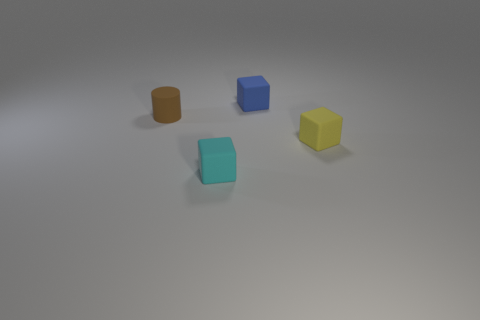Are there the same number of small cyan cubes to the left of the brown object and yellow things?
Provide a succinct answer. No. What is the shape of the cyan object that is the same size as the yellow block?
Keep it short and to the point. Cube. There is a rubber object to the left of the cyan cube; are there any tiny brown rubber things on the right side of it?
Keep it short and to the point. No. How many tiny objects are cyan blocks or cyan metal objects?
Offer a very short reply. 1. Are there any cyan things of the same size as the brown cylinder?
Provide a succinct answer. Yes. What number of metallic objects are either blue objects or small yellow things?
Provide a succinct answer. 0. How many brown cubes are there?
Provide a succinct answer. 0. Is the block to the right of the tiny blue matte block made of the same material as the cube that is behind the tiny yellow rubber object?
Give a very brief answer. Yes. What is the size of the cyan block that is the same material as the brown object?
Keep it short and to the point. Small. The object behind the cylinder has what shape?
Offer a very short reply. Cube. 